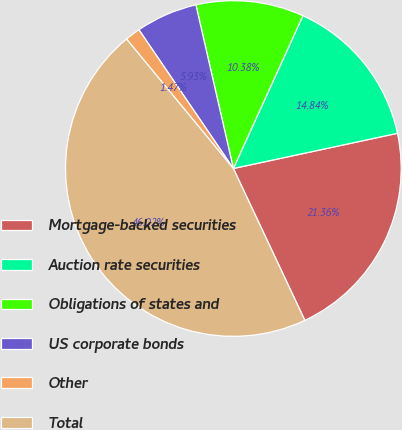Convert chart to OTSL. <chart><loc_0><loc_0><loc_500><loc_500><pie_chart><fcel>Mortgage-backed securities<fcel>Auction rate securities<fcel>Obligations of states and<fcel>US corporate bonds<fcel>Other<fcel>Total<nl><fcel>21.36%<fcel>14.84%<fcel>10.38%<fcel>5.93%<fcel>1.47%<fcel>46.02%<nl></chart> 